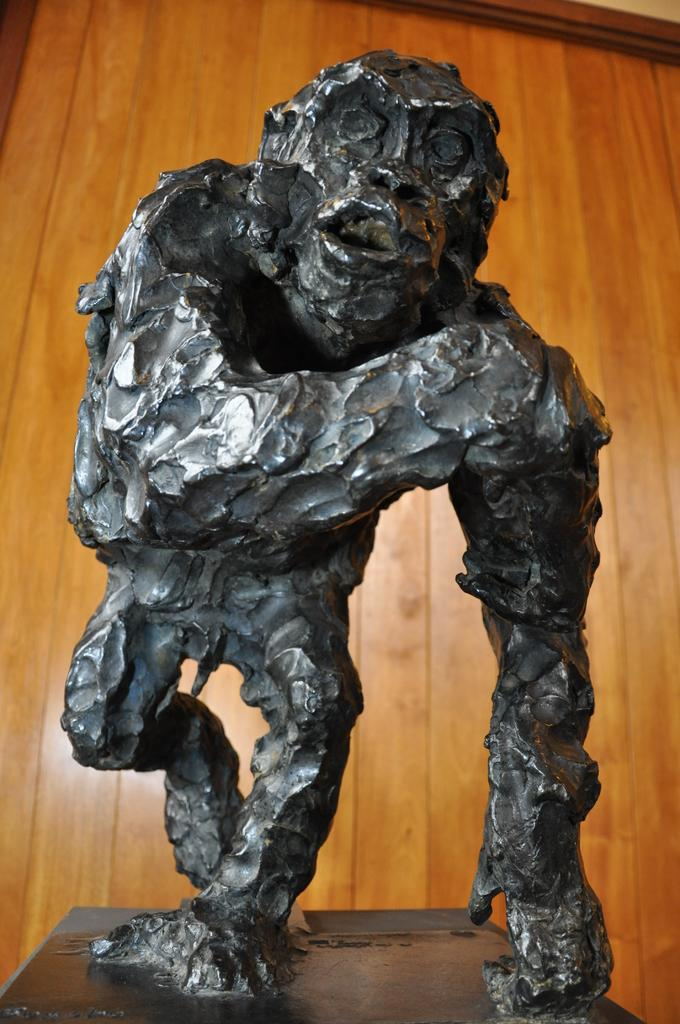What is the main subject of the image? There is a statue of a monkey in the image. What color is the statue? The statue is black in color. What can be seen in the background of the image? There is a wooden door in the background of the image. What type of news can be heard coming from the hydrant in the image? There is no hydrant present in the image, and therefore no news can be heard coming from it. 